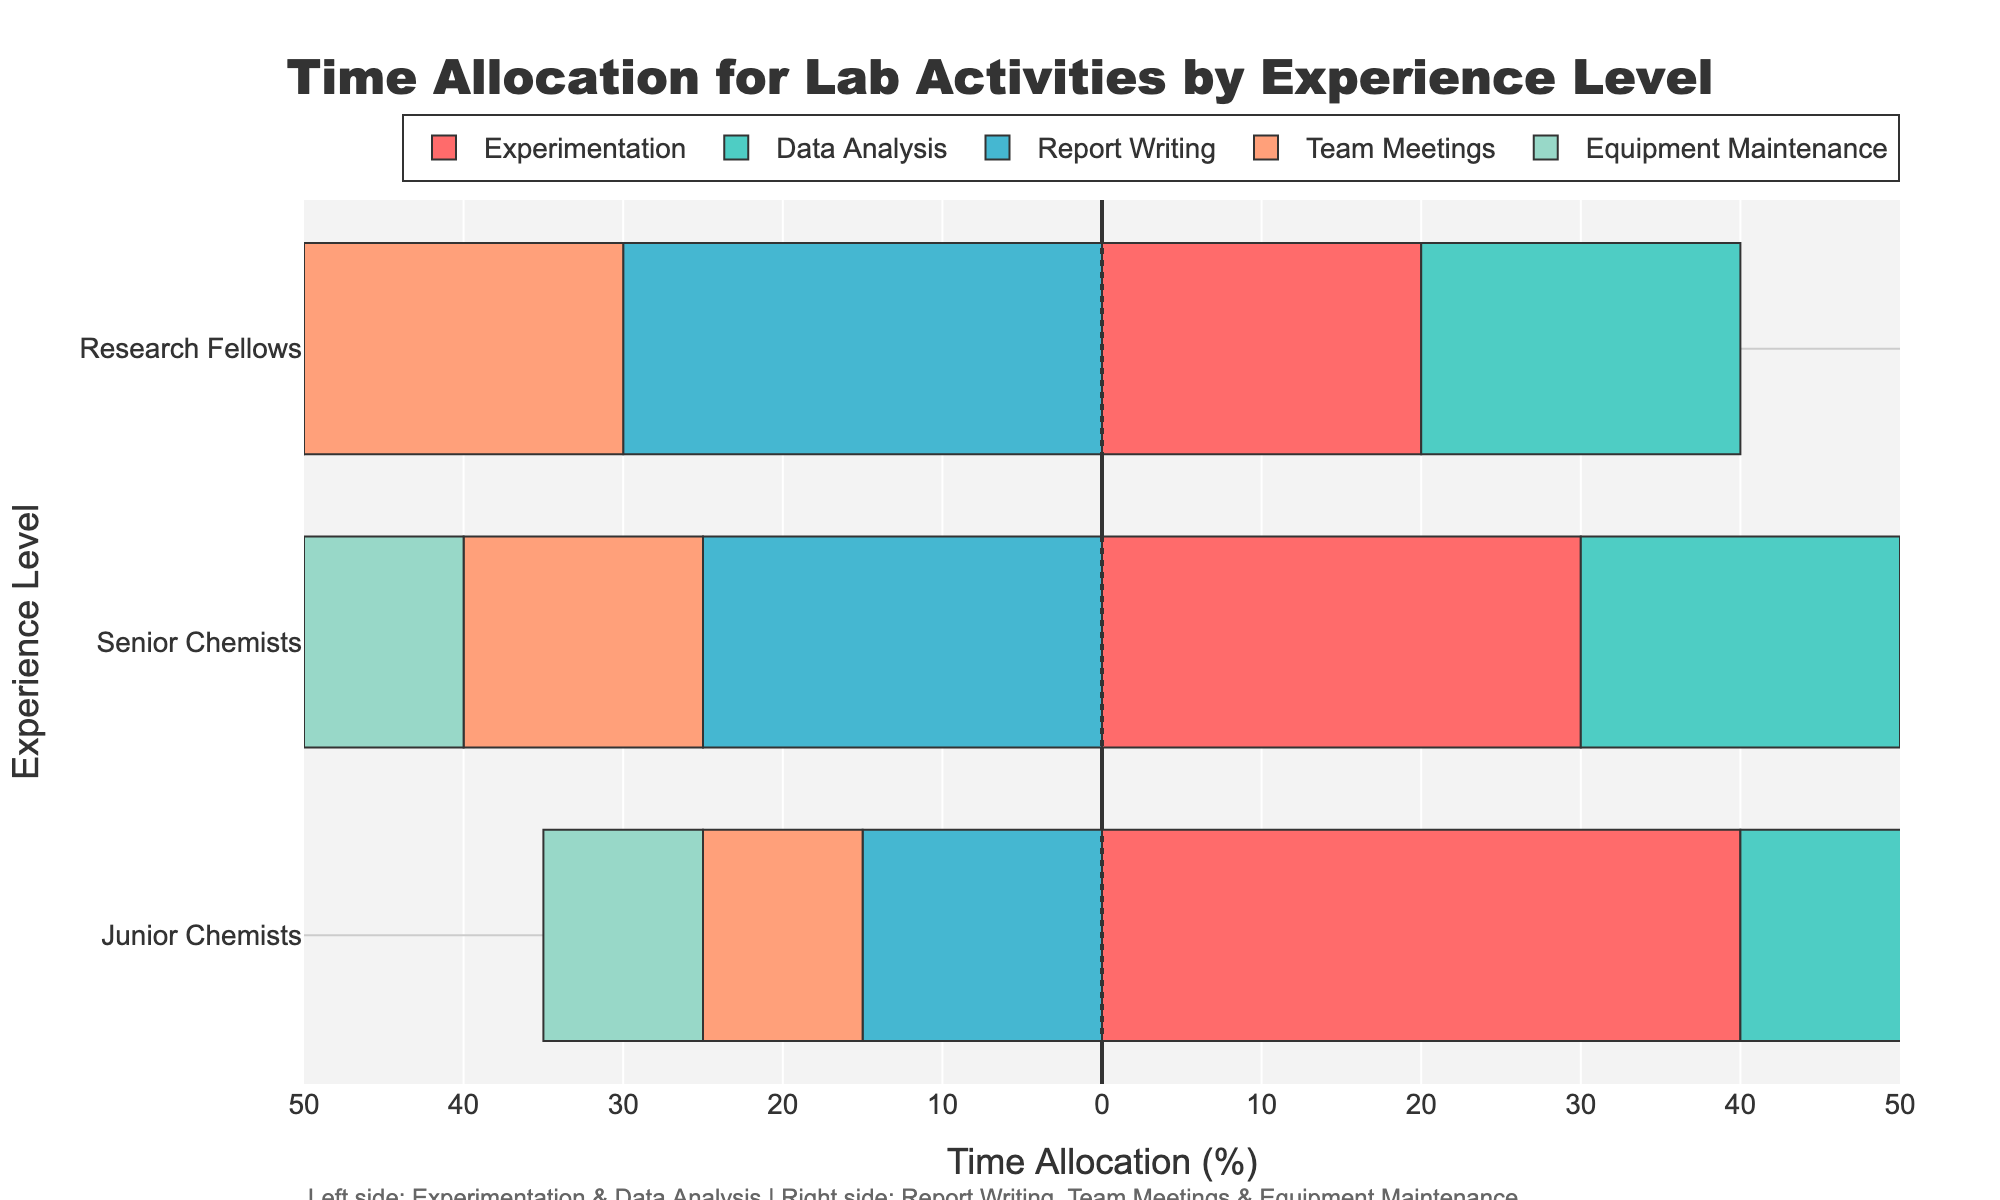what proportion of time do junior chemists spend on experimentation compared to senior chemists? The junior chemists spend 40% of their time on experimentation, while senior chemists spend 30%. To find the proportion, divide the time for junior chemists by that for senior chemists: 40% / 30% = 1.33.
Answer: 1.33 Which activity sees the highest time allocation from senior chemists? From the chart, the bar for Report Writing is the longest for senior chemists, indicating that they allocate the most time to this activity.
Answer: Report Writing How does the time allocated for data analysis compare between junior chemists and research fellows? Junior chemists allocate 25% of their time to data analysis, while research fellows allocate 20%. Comparing the two, the junior chemists spend more time on this activity.
Answer: Junior chemists spend more time Which experience level spends the least amount of time on experimentation? Research Fellows allocate 20% of their time to experimentation, which is the smallest proportion compared to Junior and Senior Chemists.
Answer: Research Fellows What is the combined time allocation for report writing and team meetings for research fellows? Research Fellows allocate 30% of their time to report writing and 20% to team meetings. Adding these together: 30% + 20% = 50%.
Answer: 50% Which group spends more time on equipment maintenance, and by how much? All experience levels allocate 10% to equipment maintenance, so there is no difference in time allocation for this activity across groups.
Answer: No difference How does the combined time for data analysis and experimentation compare between senior and junior chemists? Junior chemists' combined time: 40% (Experimentation) + 25% (Data Analysis) = 65%. Senior chemists' combined time: 30% (Experimentation) + 20% (Data Analysis) = 50%. Comparison: 65% is greater than 50%.
Answer: Junior chemists spend more Do research fellows spend equally on data analysis and team meetings? Yes, the bars for data analysis and team meetings are of equal length for research fellows, both indicating 20% time allocation.
Answer: Yes Which activity has the least variation in time allocation across all experience levels? The time allocation for Equipment Maintenance is consistently 10% across Junior Chemists, Senior Chemists, and Research Fellows, showing the least variation.
Answer: Equipment Maintenance 